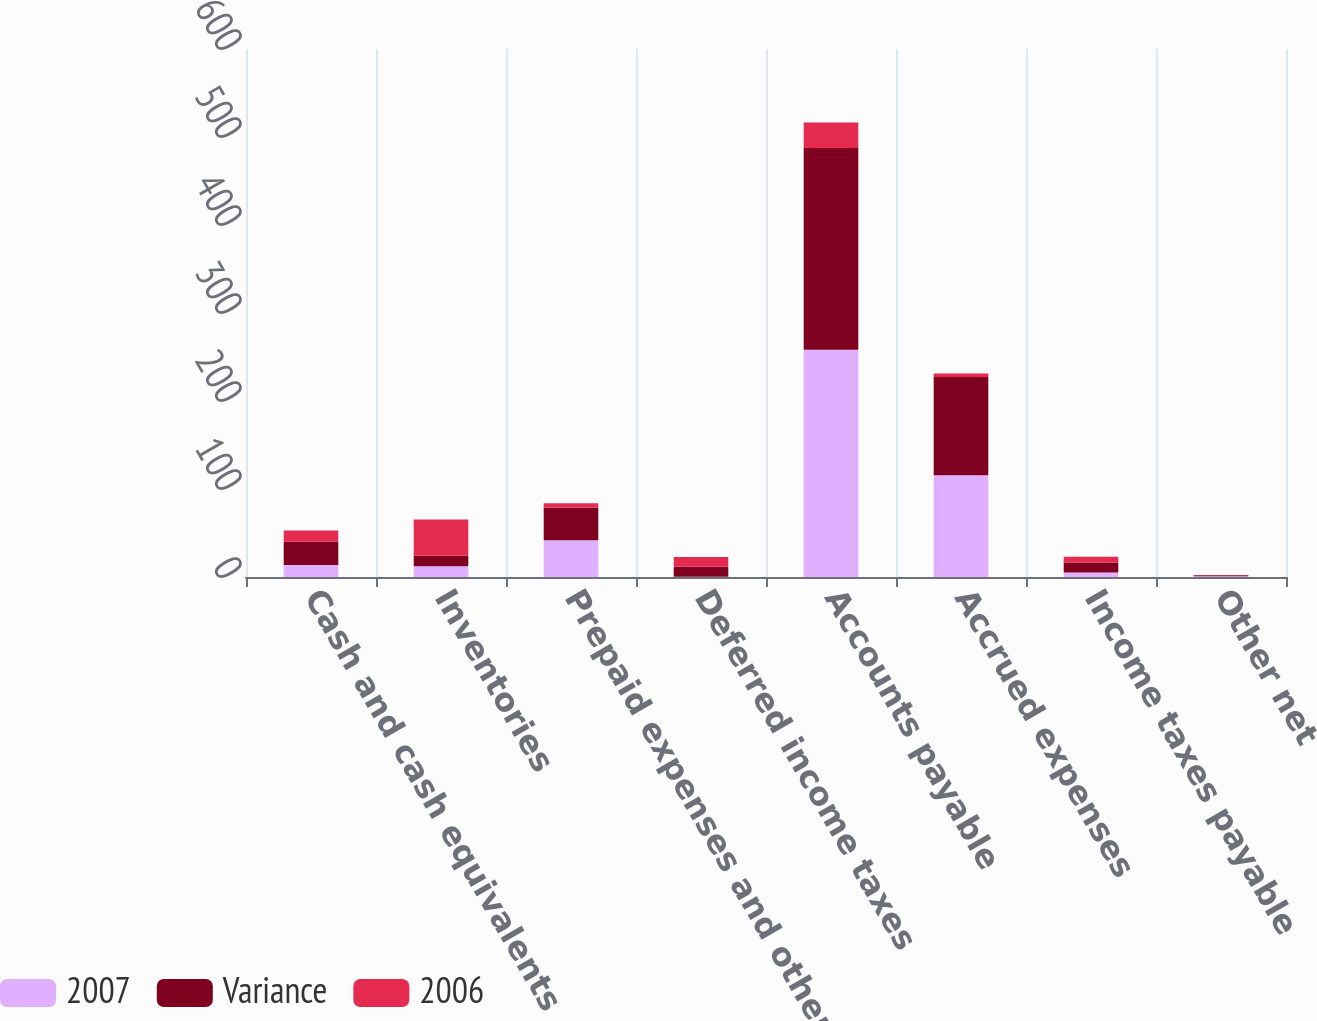Convert chart to OTSL. <chart><loc_0><loc_0><loc_500><loc_500><stacked_bar_chart><ecel><fcel>Cash and cash equivalents<fcel>Inventories<fcel>Prepaid expenses and other<fcel>Deferred income taxes<fcel>Accounts payable<fcel>Accrued expenses<fcel>Income taxes payable<fcel>Other net<nl><fcel>2007<fcel>13.7<fcel>12.1<fcel>41.9<fcel>0.3<fcel>258.3<fcel>115.6<fcel>5.1<fcel>0.8<nl><fcel>Variance<fcel>26.4<fcel>12.1<fcel>37<fcel>11.3<fcel>229.2<fcel>111.7<fcel>11.5<fcel>1.1<nl><fcel>2006<fcel>12.7<fcel>41.1<fcel>4.9<fcel>11<fcel>29.1<fcel>3.9<fcel>6.4<fcel>0.3<nl></chart> 